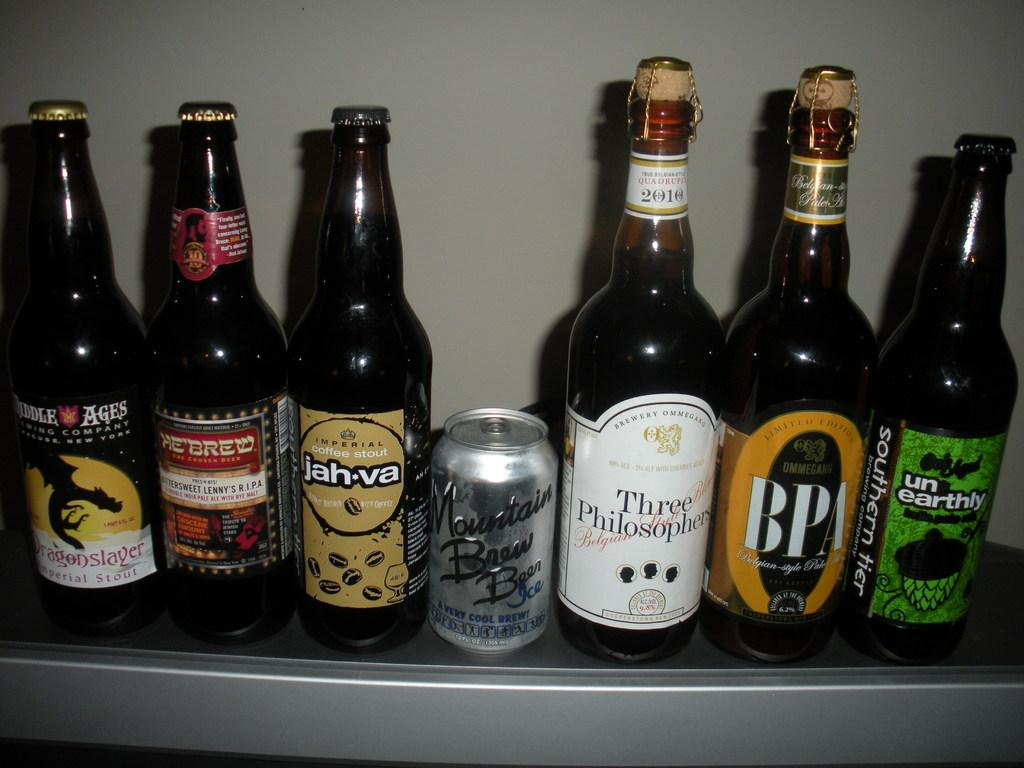<image>
Create a compact narrative representing the image presented. Bottles of booze lined up on a shelf with mountain brew being in the center. 